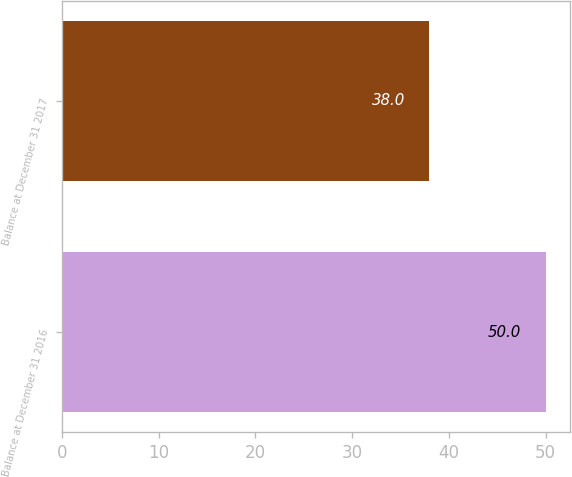Convert chart to OTSL. <chart><loc_0><loc_0><loc_500><loc_500><bar_chart><fcel>Balance at December 31 2016<fcel>Balance at December 31 2017<nl><fcel>50<fcel>38<nl></chart> 